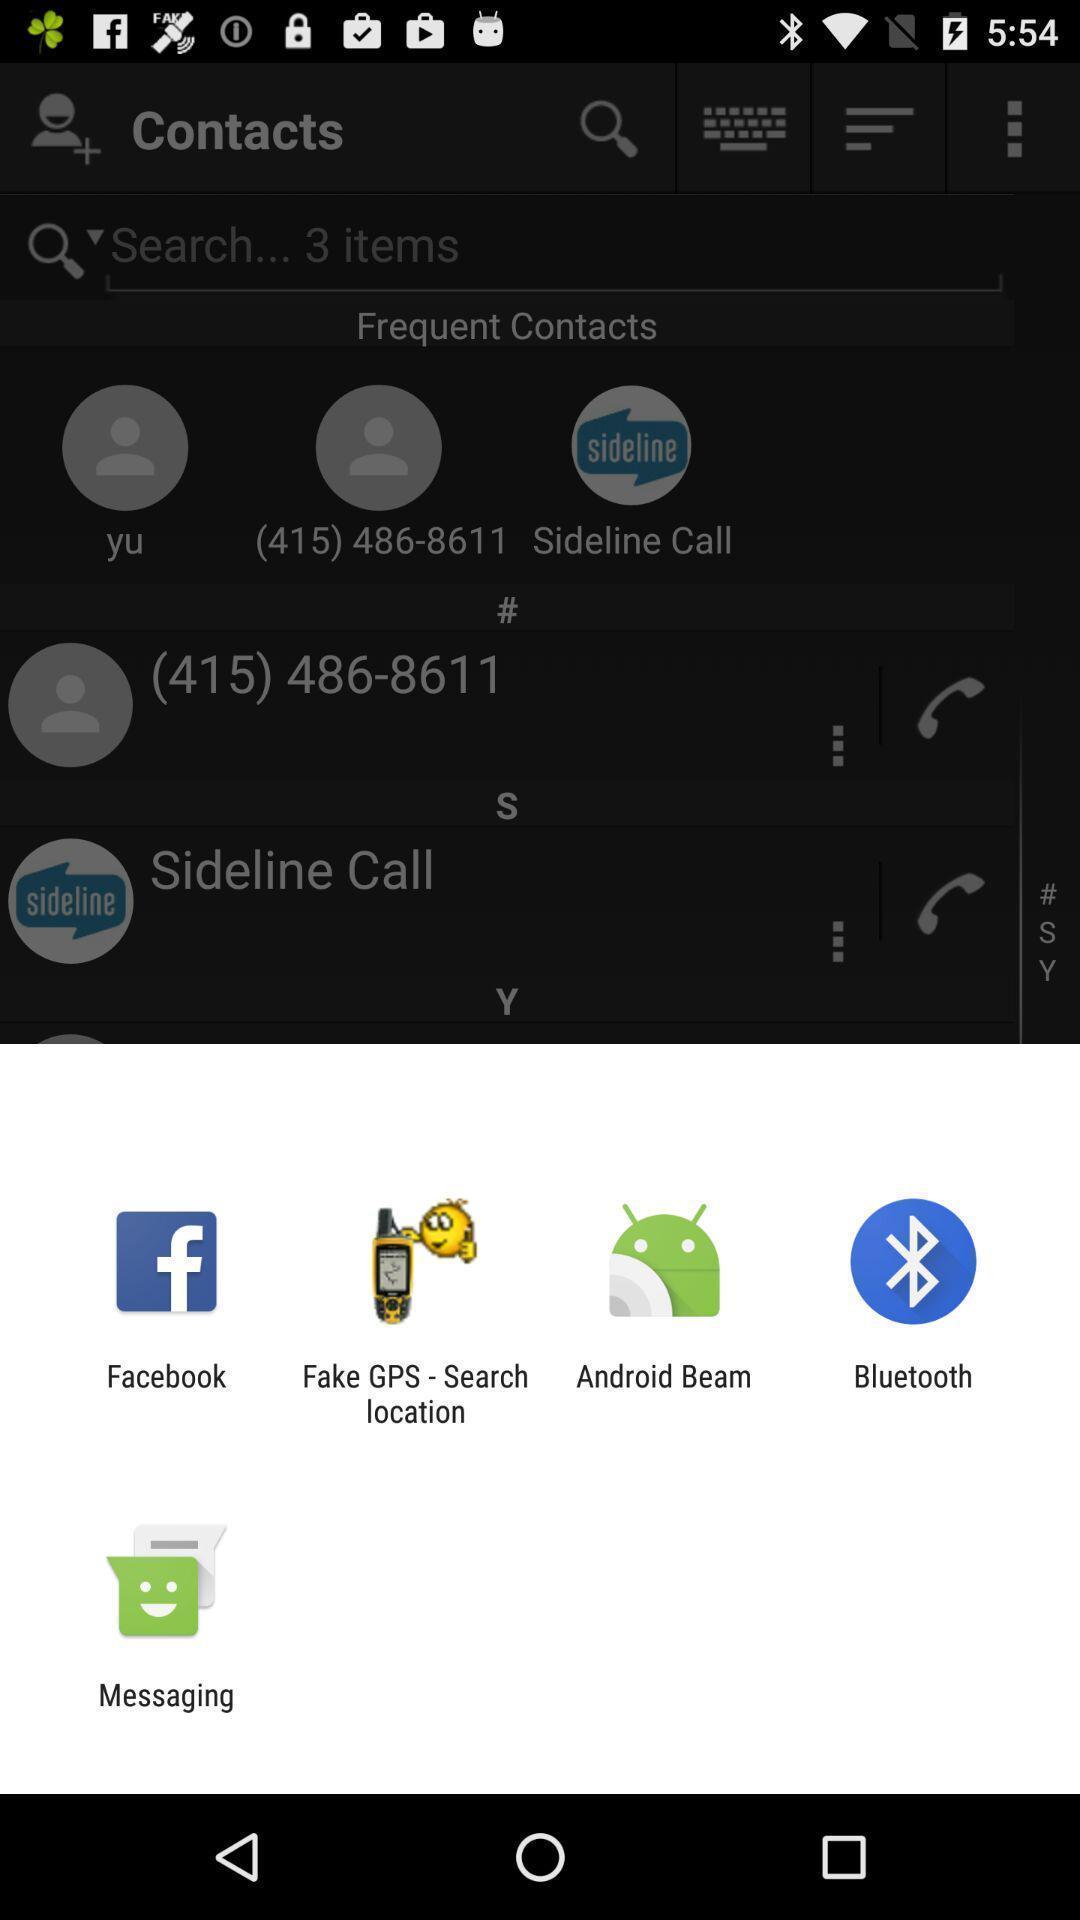What details can you identify in this image? Pop-up showing list of various applications. 